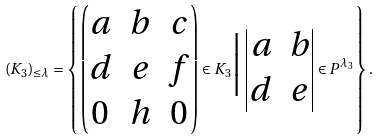Convert formula to latex. <formula><loc_0><loc_0><loc_500><loc_500>( K _ { 3 } ) _ { \leq \lambda } = \left \{ \begin{pmatrix} a & b & c \\ d & e & f \\ 0 & h & 0 \end{pmatrix} \in K _ { 3 } \Big | \begin{vmatrix} a & b \\ d & e \end{vmatrix} \in P ^ { \lambda _ { 3 } } \right \} .</formula> 